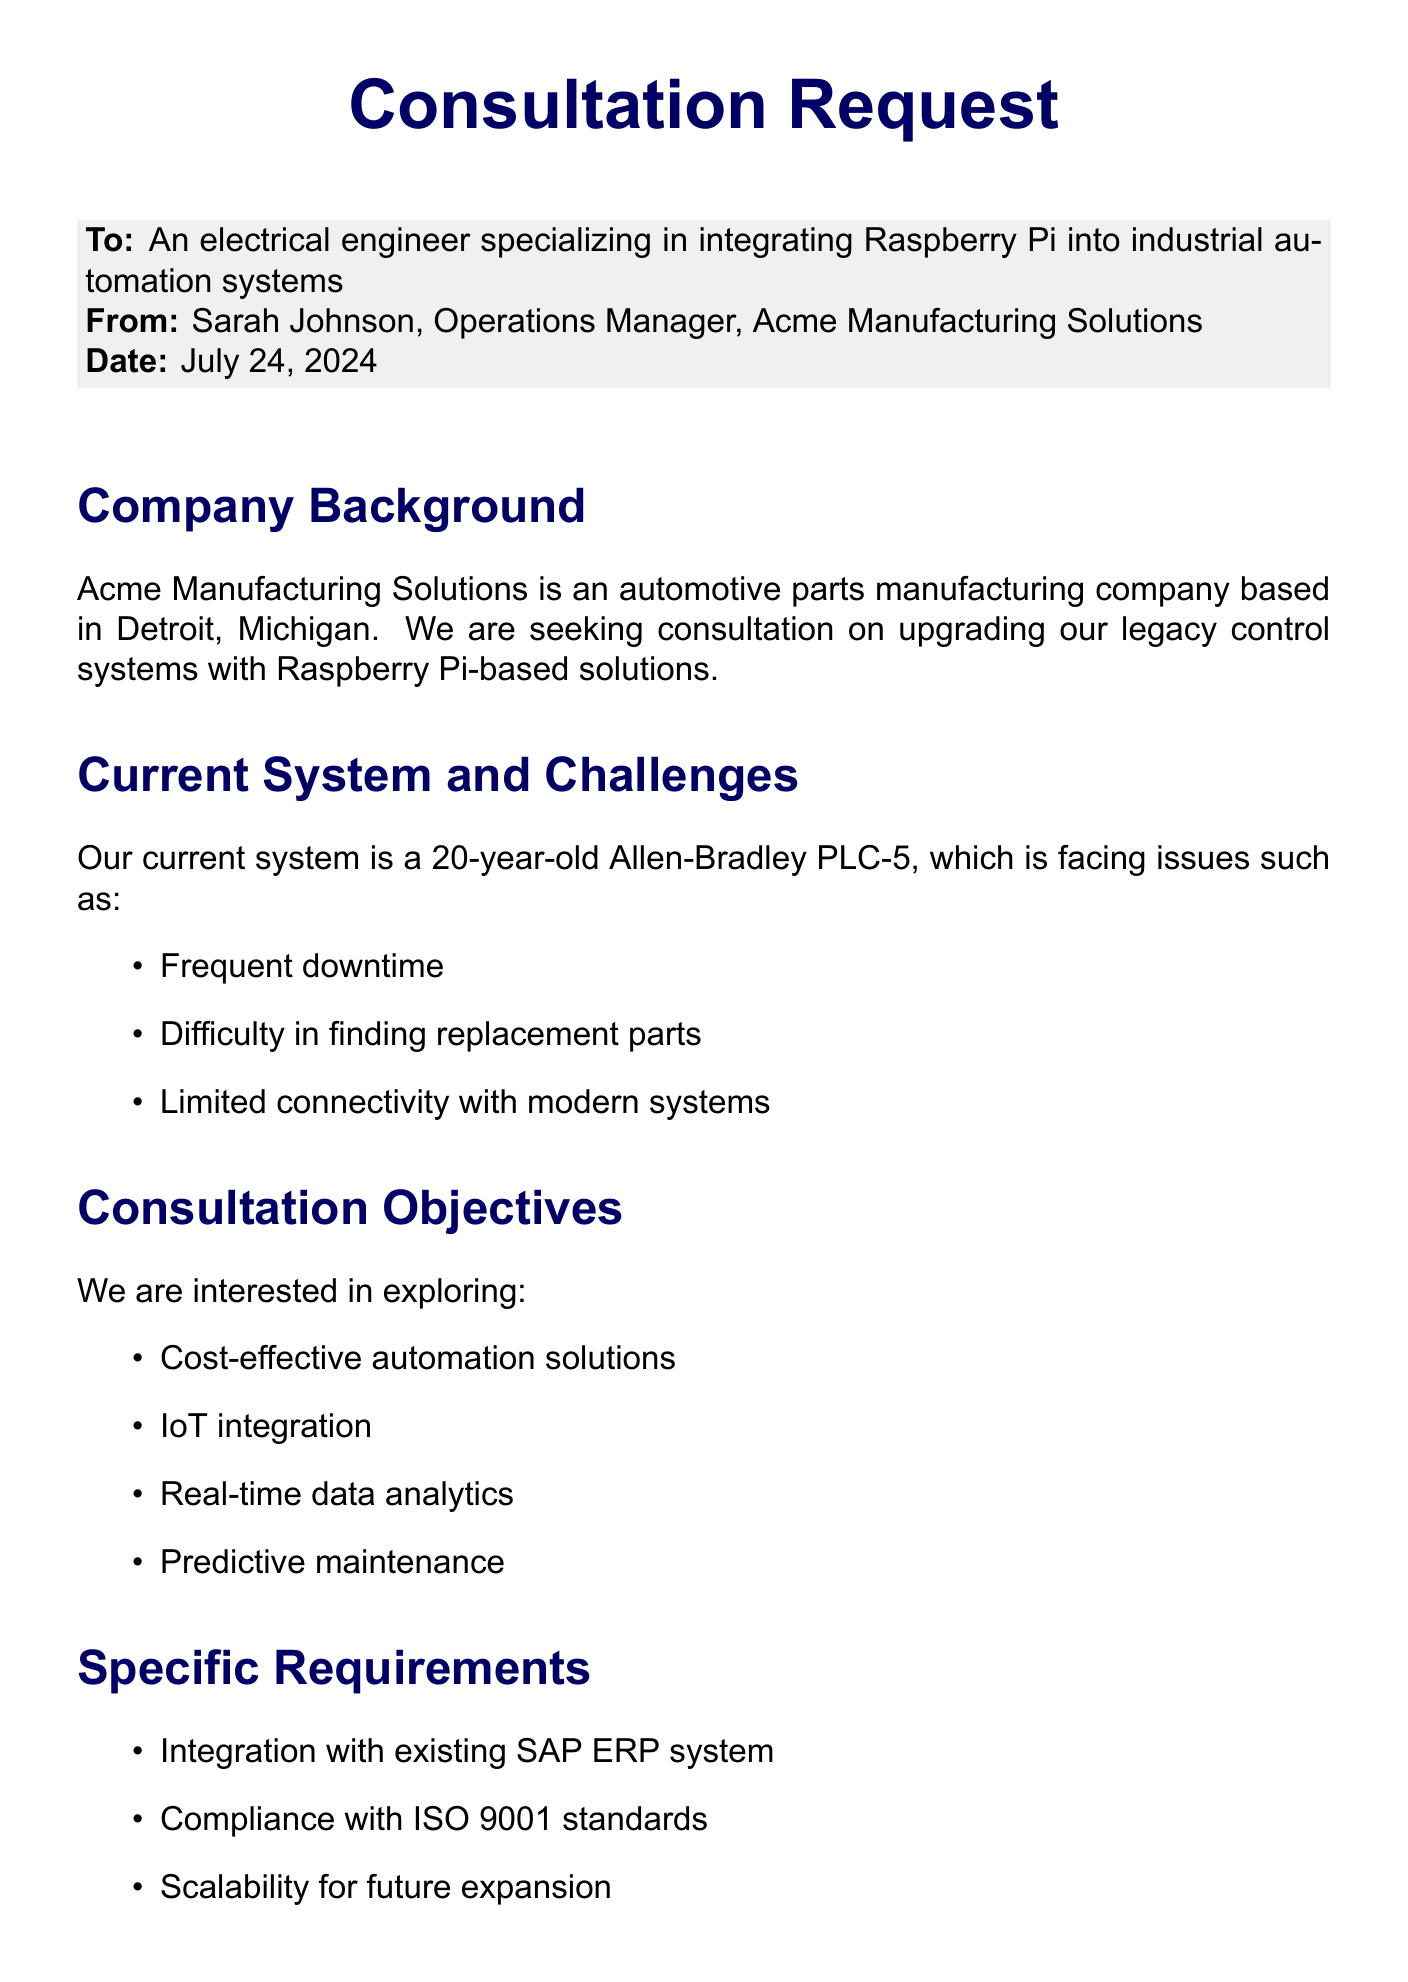what is the name of the company? The name of the company mentioned in the document is Acme Manufacturing Solutions.
Answer: Acme Manufacturing Solutions who is the contact person for the consultation? The contact person for the consultation is Sarah Johnson, who is the Operations Manager.
Answer: Sarah Johnson what is the current control system used by the company? The current control system used by the company is an Allen-Bradley PLC-5.
Answer: Allen-Bradley PLC-5 how many years old is the current control system? The current control system is 20 years old.
Answer: 20 years what are one of the desired outcomes of the consultation? One of the desired outcomes is to increase production efficiency.
Answer: Increased production efficiency what is the budget range allocated for this project? The budget range allocated for this project is between $100,000 and $250,000.
Answer: $100,000 - $250,000 what is one specific requirement mentioned for the consultation? One specific requirement is integration with the existing SAP ERP system.
Answer: Integration with existing SAP ERP system what are the preferred dates for the proposed meeting? The preferred dates for the proposed meeting are July 15 and July 22, 2023.
Answer: July 15, July 22 what type of consultation is requested? The type of consultation requested is an on-site consultation.
Answer: On-site consultation 